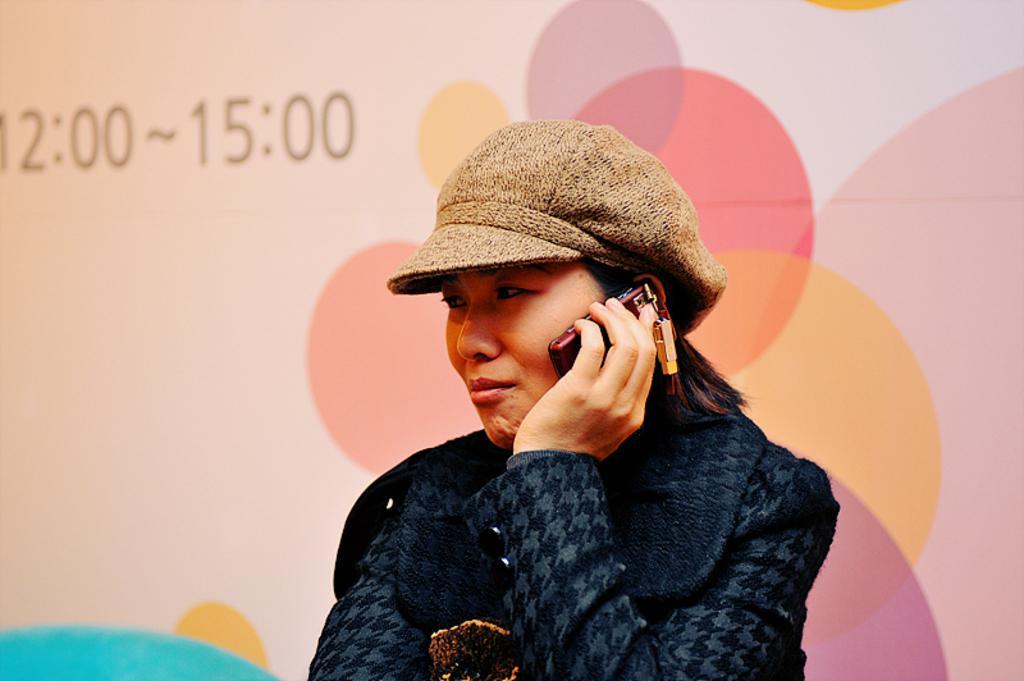Describe this image in one or two sentences. In this image I see a woman who is wearing blue dress and I see that she is also wearing a cap which is of brown in color and I see that she is holding a phone near to her ear and in the background I see the screen on which I see the numbers and it is colorful. 